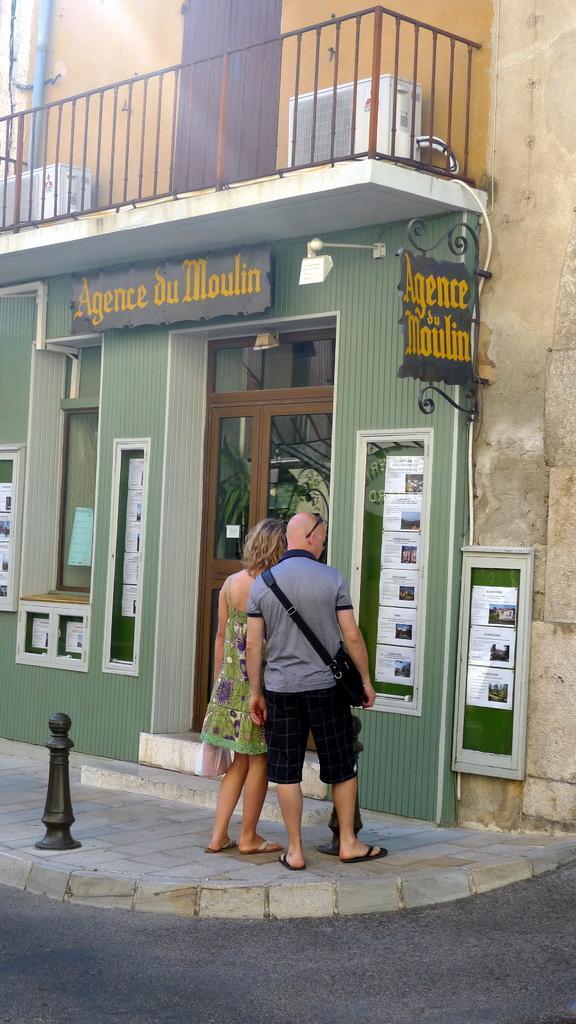In one or two sentences, can you explain what this image depicts? In the center of the image there is a man and woman standing on the ground. In the background we can see door, windows and building. 